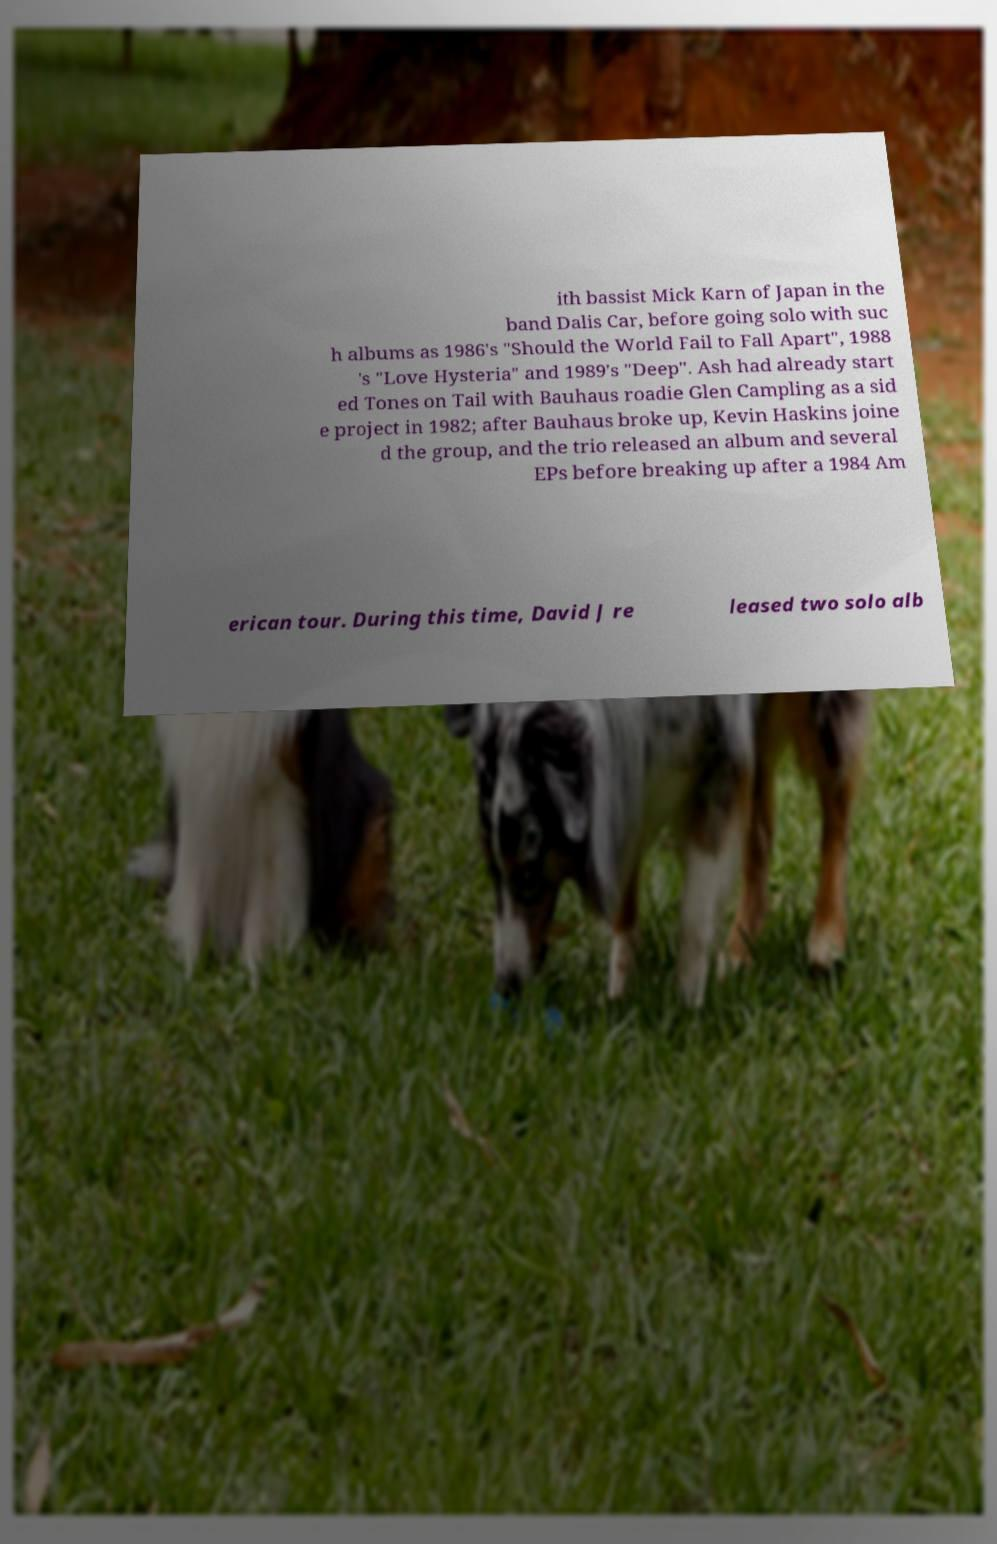I need the written content from this picture converted into text. Can you do that? ith bassist Mick Karn of Japan in the band Dalis Car, before going solo with suc h albums as 1986's "Should the World Fail to Fall Apart", 1988 's "Love Hysteria" and 1989's "Deep". Ash had already start ed Tones on Tail with Bauhaus roadie Glen Campling as a sid e project in 1982; after Bauhaus broke up, Kevin Haskins joine d the group, and the trio released an album and several EPs before breaking up after a 1984 Am erican tour. During this time, David J re leased two solo alb 